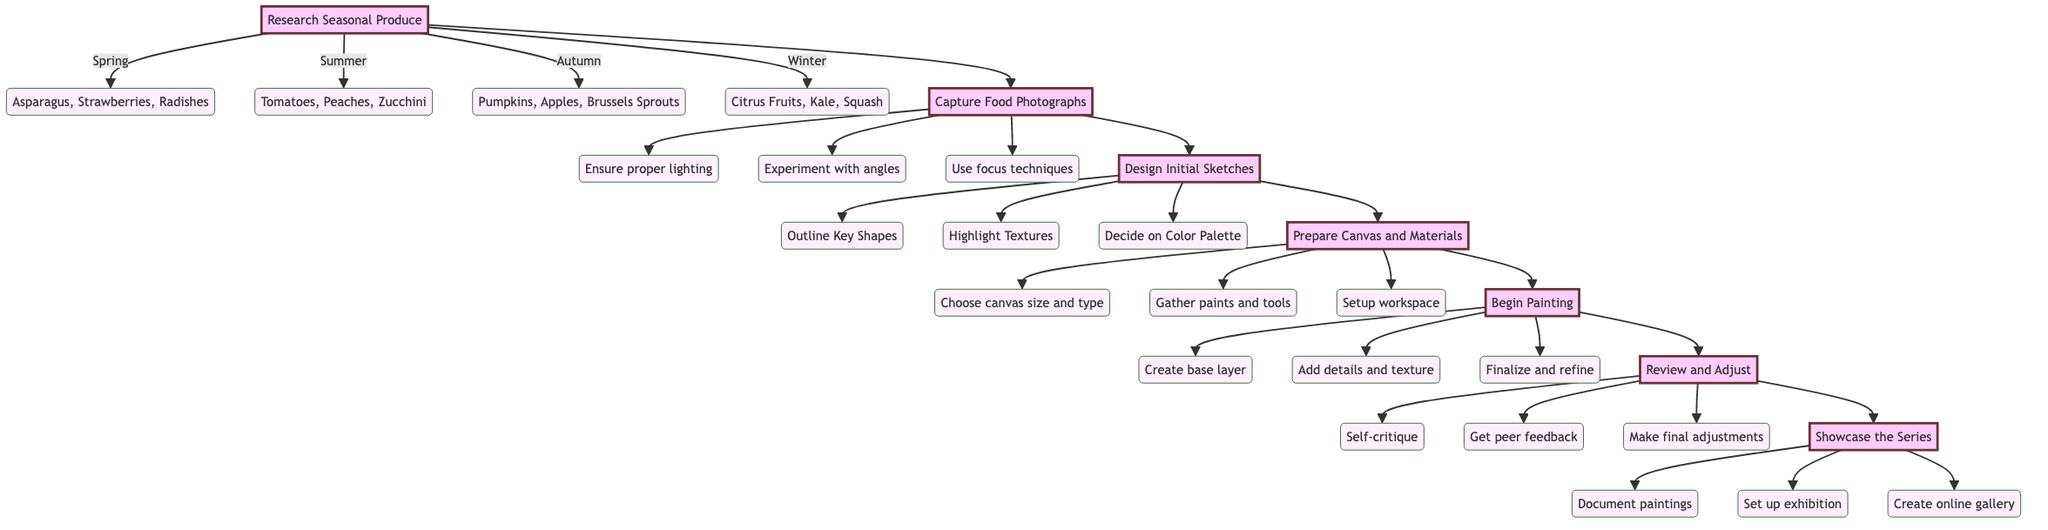What is the first step in the flowchart? The diagram shows that the first step is "Research Seasonal Produce," which is the starting point of the process.
Answer: Research Seasonal Produce How many seasons are mentioned in the diagram? There are four seasons listed in the diagram: Spring, Summer, Autumn, and Winter. By counting the distinct substeps under the main step "Research Seasonal Produce," we find a total of four.
Answer: Four What is the substep under "Capture Food Photographs" that focuses on light? The substep that focuses on lighting is "Ensure proper natural lighting to highlight vibrant colors and textures." This is directly called out under the "Capture Food Photographs" step.
Answer: Ensure proper lighting Which step comes after "Prepare Canvas and Materials"? The step that follows "Prepare Canvas and Materials" is "Begin Painting." This indicates a clear sequence in the flow of the painting process.
Answer: Begin Painting In which step do you add layers to build texture? You add layers to build texture in the step "Begin Painting," specifically under the substep "Add Details." This substep is focused on enhancing the painting's depth and texture.
Answer: Begin Painting What is the last step before showcasing the series? The last step before showcasing the series is "Review and Adjust." This step involves critiquing and making adjustments to ensure the painting aligns with the artist's vision.
Answer: Review and Adjust How many substeps are there in the "Review and Adjust" step? The "Review and Adjust" step has three substeps: "Self-Critique," "Peer Feedback," and "Adjustments." The count provides insight into the evaluation process in the flowchart.
Answer: Three What is the common focus of the steps leading up to "Begin Painting"? The common focus of the steps leading up to "Begin Painting" is preparing and planning, including researching, capturing photographs, designing sketches, and preparing materials. All these steps build a foundation for the actual painting process.
Answer: Preparation and planning 